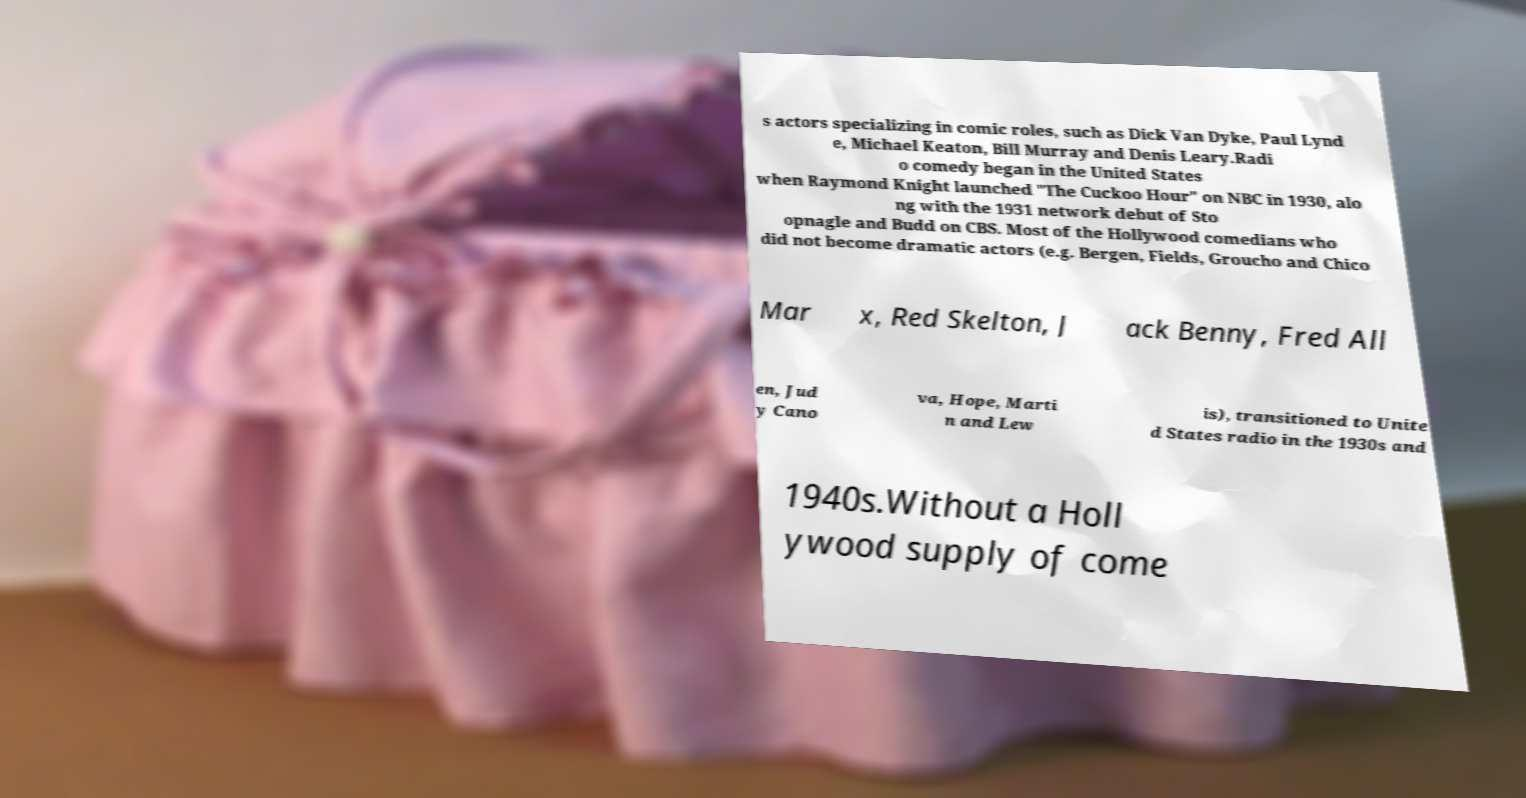Can you read and provide the text displayed in the image?This photo seems to have some interesting text. Can you extract and type it out for me? s actors specializing in comic roles, such as Dick Van Dyke, Paul Lynd e, Michael Keaton, Bill Murray and Denis Leary.Radi o comedy began in the United States when Raymond Knight launched "The Cuckoo Hour" on NBC in 1930, alo ng with the 1931 network debut of Sto opnagle and Budd on CBS. Most of the Hollywood comedians who did not become dramatic actors (e.g. Bergen, Fields, Groucho and Chico Mar x, Red Skelton, J ack Benny, Fred All en, Jud y Cano va, Hope, Marti n and Lew is), transitioned to Unite d States radio in the 1930s and 1940s.Without a Holl ywood supply of come 